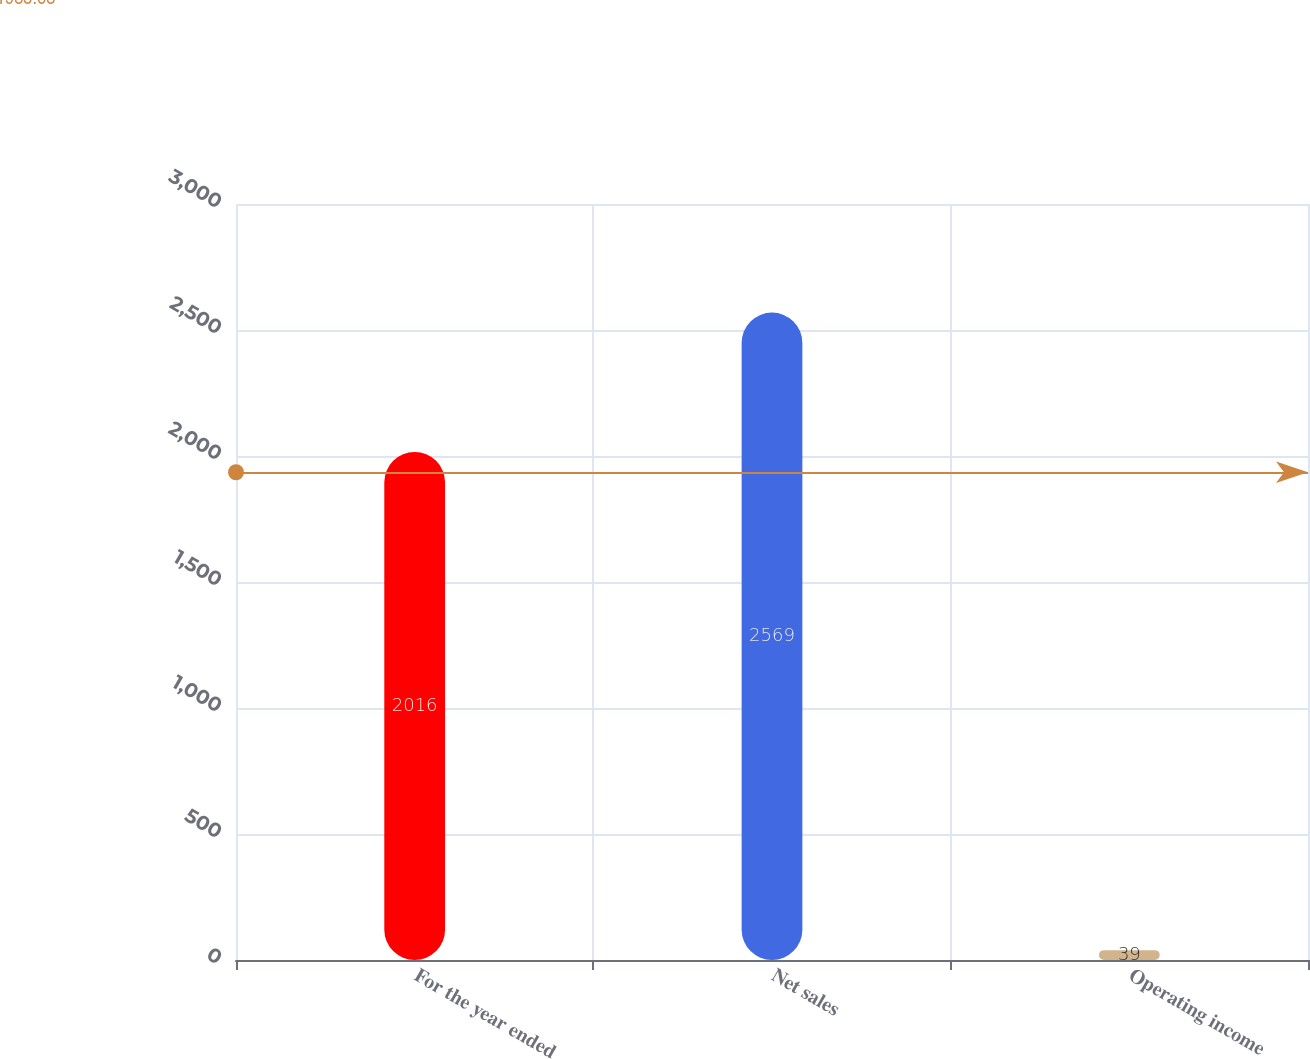<chart> <loc_0><loc_0><loc_500><loc_500><bar_chart><fcel>For the year ended<fcel>Net sales<fcel>Operating income<nl><fcel>2016<fcel>2569<fcel>39<nl></chart> 